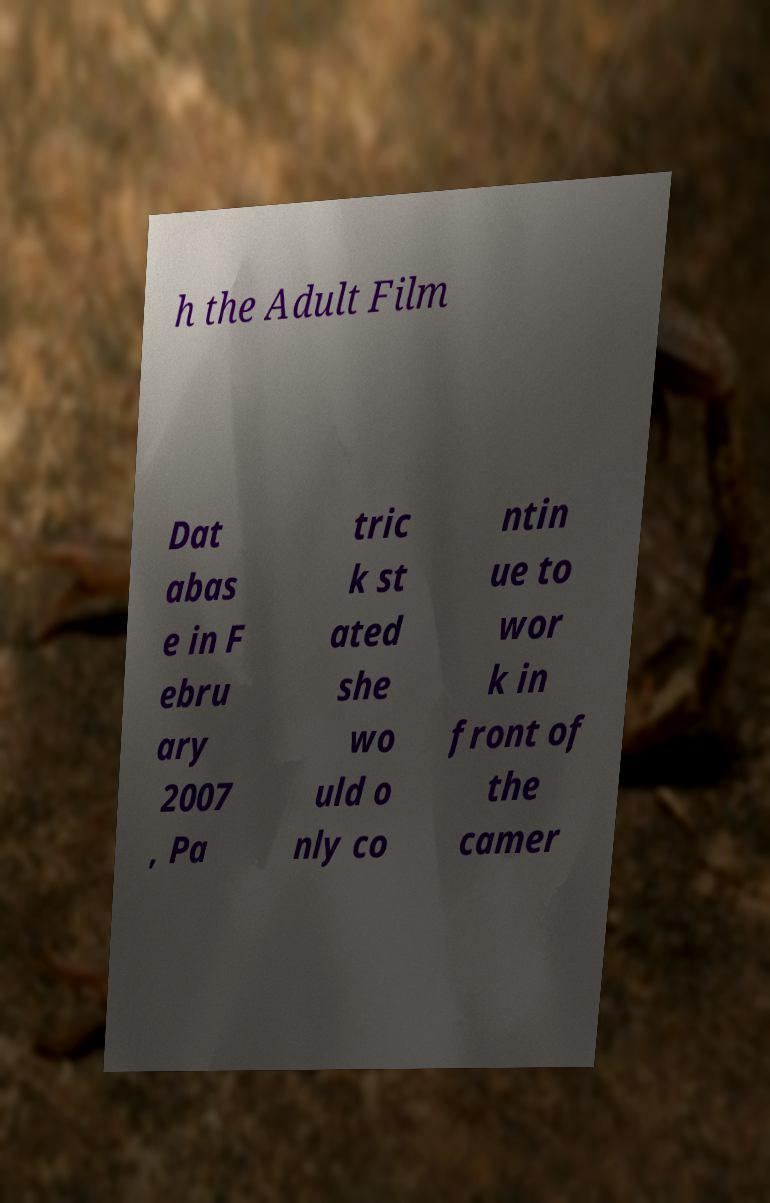Can you accurately transcribe the text from the provided image for me? h the Adult Film Dat abas e in F ebru ary 2007 , Pa tric k st ated she wo uld o nly co ntin ue to wor k in front of the camer 